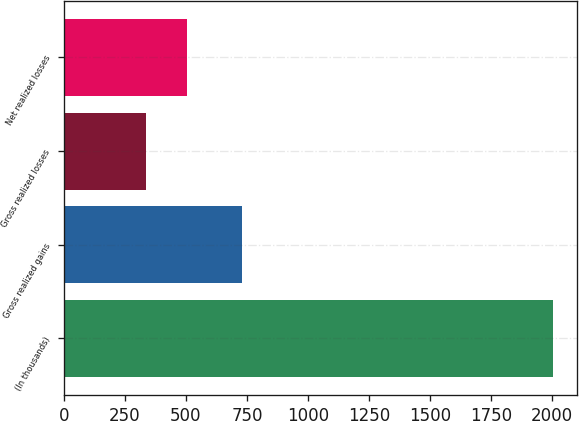Convert chart to OTSL. <chart><loc_0><loc_0><loc_500><loc_500><bar_chart><fcel>(In thousands)<fcel>Gross realized gains<fcel>Gross realized losses<fcel>Net realized losses<nl><fcel>2004<fcel>728<fcel>337<fcel>503.7<nl></chart> 